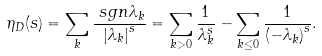Convert formula to latex. <formula><loc_0><loc_0><loc_500><loc_500>\eta _ { D } ( s ) & = \sum _ { k } \frac { \ s g n \lambda _ { k } } { { | \lambda _ { k } | } ^ { s } } = \sum _ { k > 0 } \frac { 1 } { \lambda _ { k } ^ { s } } - \sum _ { k \leq 0 } \frac { 1 } { { ( - \lambda _ { k } ) } ^ { s } } .</formula> 